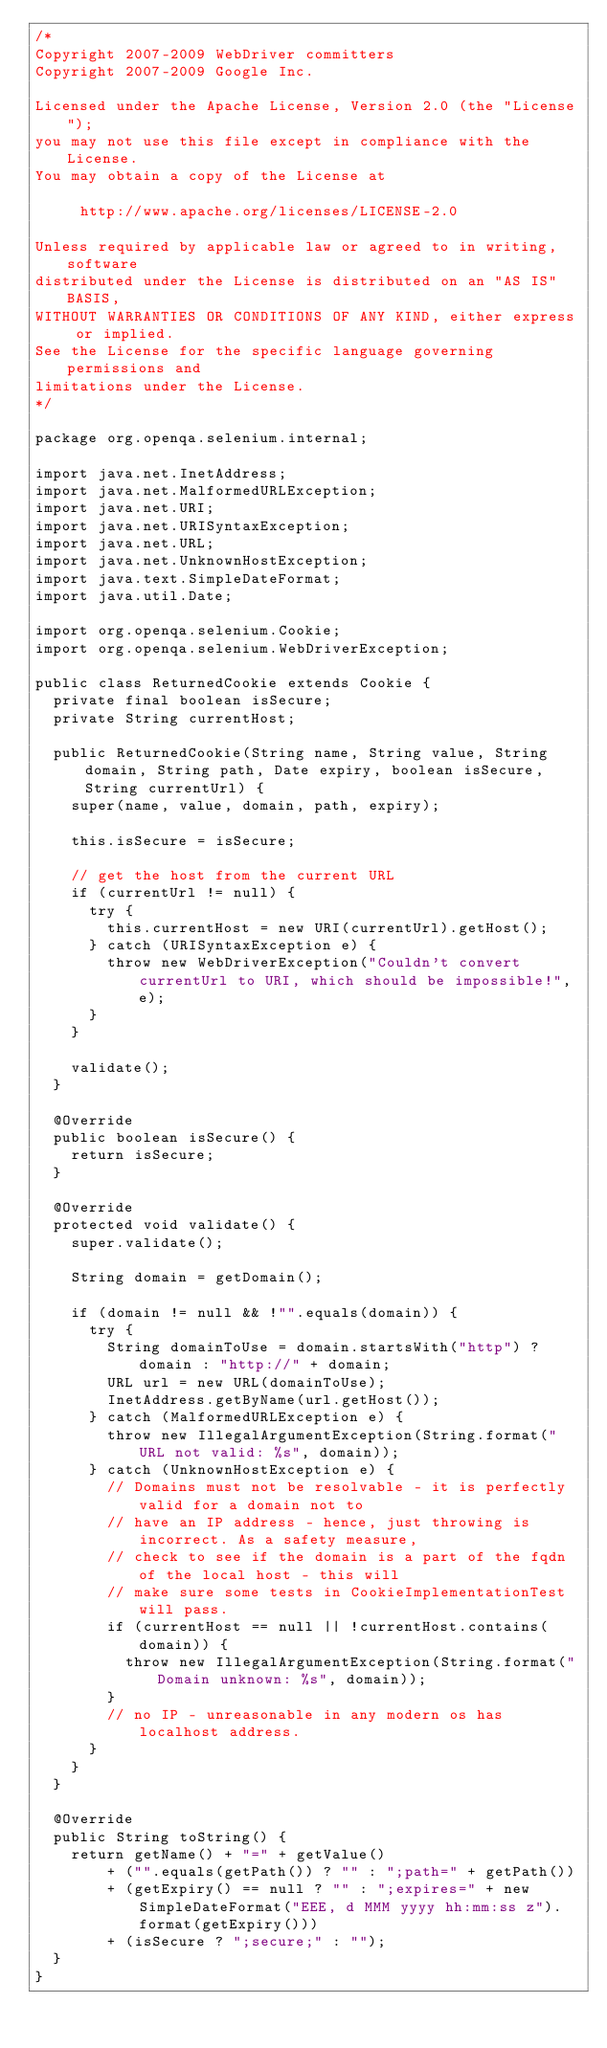Convert code to text. <code><loc_0><loc_0><loc_500><loc_500><_Java_>/*
Copyright 2007-2009 WebDriver committers
Copyright 2007-2009 Google Inc.

Licensed under the Apache License, Version 2.0 (the "License");
you may not use this file except in compliance with the License.
You may obtain a copy of the License at

     http://www.apache.org/licenses/LICENSE-2.0

Unless required by applicable law or agreed to in writing, software
distributed under the License is distributed on an "AS IS" BASIS,
WITHOUT WARRANTIES OR CONDITIONS OF ANY KIND, either express or implied.
See the License for the specific language governing permissions and
limitations under the License.
*/

package org.openqa.selenium.internal;

import java.net.InetAddress;
import java.net.MalformedURLException;
import java.net.URI;
import java.net.URISyntaxException;
import java.net.URL;
import java.net.UnknownHostException;
import java.text.SimpleDateFormat;
import java.util.Date;

import org.openqa.selenium.Cookie;
import org.openqa.selenium.WebDriverException;

public class ReturnedCookie extends Cookie {
  private final boolean isSecure;
  private String currentHost;

  public ReturnedCookie(String name, String value, String domain, String path, Date expiry, boolean isSecure, String currentUrl) {
    super(name, value, domain, path, expiry);

    this.isSecure = isSecure;

    // get the host from the current URL
    if (currentUrl != null) {
      try {
        this.currentHost = new URI(currentUrl).getHost();
      } catch (URISyntaxException e) {
        throw new WebDriverException("Couldn't convert currentUrl to URI, which should be impossible!", e);
      }
    }

    validate();
  }

  @Override
  public boolean isSecure() {
    return isSecure;
  }

  @Override
  protected void validate() {
    super.validate();

    String domain = getDomain();

    if (domain != null && !"".equals(domain)) {
      try {
        String domainToUse = domain.startsWith("http") ? domain : "http://" + domain;
        URL url = new URL(domainToUse);
        InetAddress.getByName(url.getHost());
      } catch (MalformedURLException e) {
        throw new IllegalArgumentException(String.format("URL not valid: %s", domain));
      } catch (UnknownHostException e) {
        // Domains must not be resolvable - it is perfectly valid for a domain not to
        // have an IP address - hence, just throwing is incorrect. As a safety measure,
        // check to see if the domain is a part of the fqdn of the local host - this will
        // make sure some tests in CookieImplementationTest will pass.
        if (currentHost == null || !currentHost.contains(domain)) {
          throw new IllegalArgumentException(String.format("Domain unknown: %s", domain));
        }
        // no IP - unreasonable in any modern os has localhost address.
      }
    }
  }

  @Override
  public String toString() {
    return getName() + "=" + getValue()
        + ("".equals(getPath()) ? "" : ";path=" + getPath())
        + (getExpiry() == null ? "" : ";expires=" + new SimpleDateFormat("EEE, d MMM yyyy hh:mm:ss z").format(getExpiry()))
        + (isSecure ? ";secure;" : "");
  }
}
</code> 